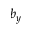<formula> <loc_0><loc_0><loc_500><loc_500>b _ { y }</formula> 